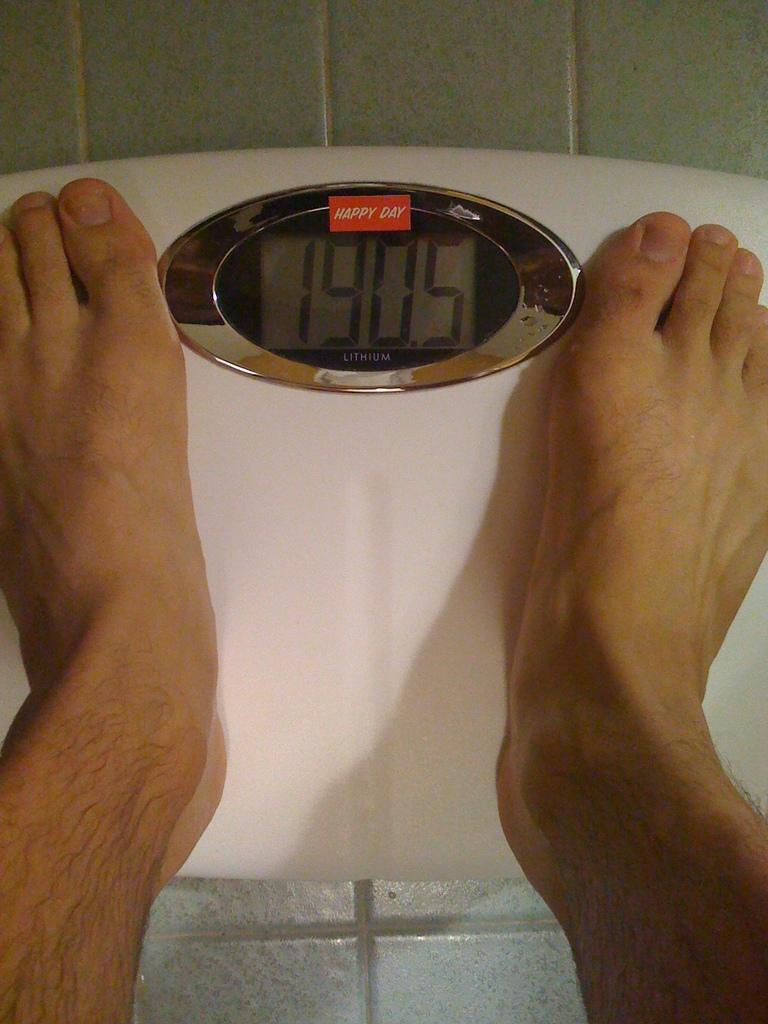<image>
Provide a brief description of the given image. a scale that has 1905 on it as the person stands 